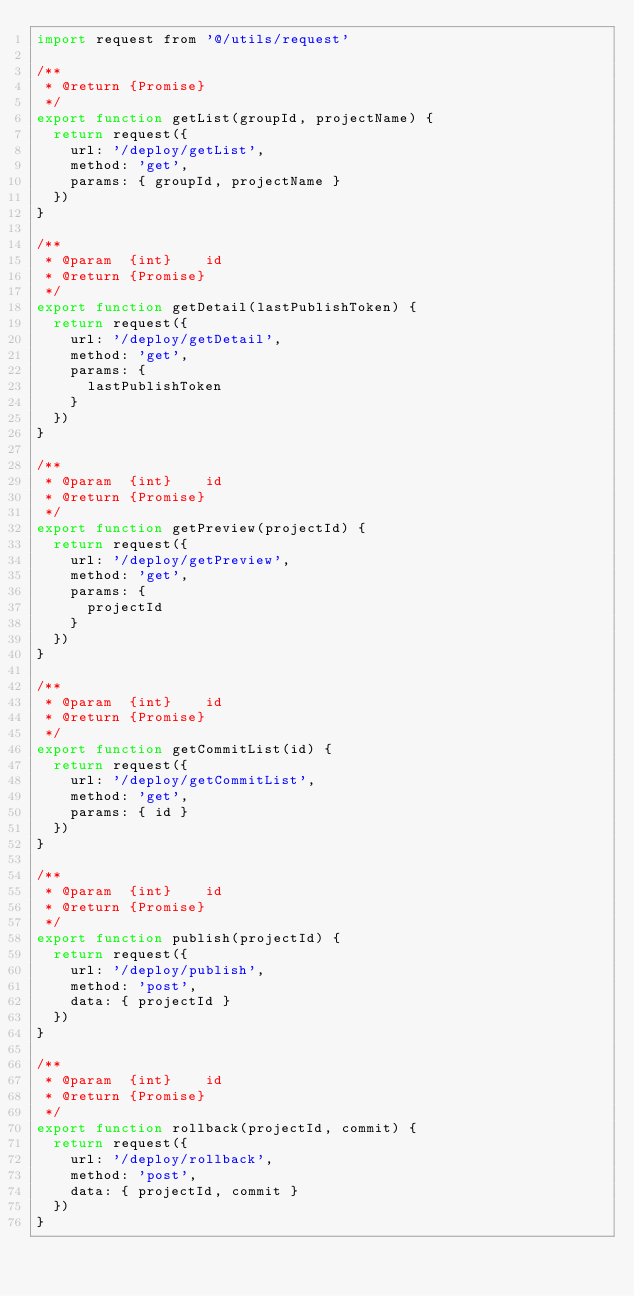Convert code to text. <code><loc_0><loc_0><loc_500><loc_500><_JavaScript_>import request from '@/utils/request'

/**
 * @return {Promise}
 */
export function getList(groupId, projectName) {
  return request({
    url: '/deploy/getList',
    method: 'get',
    params: { groupId, projectName }
  })
}

/**
 * @param  {int}    id
 * @return {Promise}
 */
export function getDetail(lastPublishToken) {
  return request({
    url: '/deploy/getDetail',
    method: 'get',
    params: {
      lastPublishToken
    }
  })
}

/**
 * @param  {int}    id
 * @return {Promise}
 */
export function getPreview(projectId) {
  return request({
    url: '/deploy/getPreview',
    method: 'get',
    params: {
      projectId
    }
  })
}

/**
 * @param  {int}    id
 * @return {Promise}
 */
export function getCommitList(id) {
  return request({
    url: '/deploy/getCommitList',
    method: 'get',
    params: { id }
  })
}

/**
 * @param  {int}    id
 * @return {Promise}
 */
export function publish(projectId) {
  return request({
    url: '/deploy/publish',
    method: 'post',
    data: { projectId }
  })
}

/**
 * @param  {int}    id
 * @return {Promise}
 */
export function rollback(projectId, commit) {
  return request({
    url: '/deploy/rollback',
    method: 'post',
    data: { projectId, commit }
  })
}
</code> 